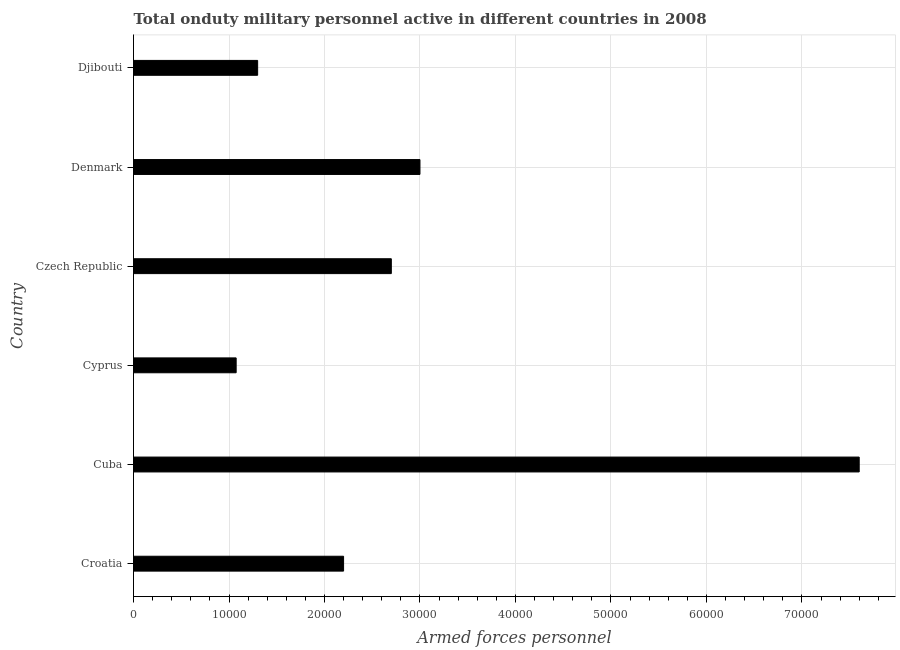Does the graph contain any zero values?
Give a very brief answer. No. Does the graph contain grids?
Your response must be concise. Yes. What is the title of the graph?
Offer a terse response. Total onduty military personnel active in different countries in 2008. What is the label or title of the X-axis?
Your response must be concise. Armed forces personnel. What is the number of armed forces personnel in Cuba?
Offer a very short reply. 7.60e+04. Across all countries, what is the maximum number of armed forces personnel?
Your answer should be compact. 7.60e+04. Across all countries, what is the minimum number of armed forces personnel?
Provide a succinct answer. 1.08e+04. In which country was the number of armed forces personnel maximum?
Your answer should be compact. Cuba. In which country was the number of armed forces personnel minimum?
Your answer should be very brief. Cyprus. What is the sum of the number of armed forces personnel?
Ensure brevity in your answer.  1.79e+05. What is the difference between the number of armed forces personnel in Cuba and Denmark?
Offer a terse response. 4.60e+04. What is the average number of armed forces personnel per country?
Give a very brief answer. 2.98e+04. What is the median number of armed forces personnel?
Offer a terse response. 2.45e+04. In how many countries, is the number of armed forces personnel greater than 70000 ?
Your response must be concise. 1. What is the ratio of the number of armed forces personnel in Denmark to that in Djibouti?
Offer a terse response. 2.31. Is the number of armed forces personnel in Czech Republic less than that in Djibouti?
Ensure brevity in your answer.  No. Is the difference between the number of armed forces personnel in Cuba and Denmark greater than the difference between any two countries?
Your answer should be very brief. No. What is the difference between the highest and the second highest number of armed forces personnel?
Offer a very short reply. 4.60e+04. Is the sum of the number of armed forces personnel in Cuba and Cyprus greater than the maximum number of armed forces personnel across all countries?
Provide a succinct answer. Yes. What is the difference between the highest and the lowest number of armed forces personnel?
Ensure brevity in your answer.  6.52e+04. What is the difference between two consecutive major ticks on the X-axis?
Make the answer very short. 10000. Are the values on the major ticks of X-axis written in scientific E-notation?
Provide a succinct answer. No. What is the Armed forces personnel of Croatia?
Give a very brief answer. 2.20e+04. What is the Armed forces personnel of Cuba?
Your answer should be very brief. 7.60e+04. What is the Armed forces personnel of Cyprus?
Your answer should be very brief. 1.08e+04. What is the Armed forces personnel of Czech Republic?
Keep it short and to the point. 2.70e+04. What is the Armed forces personnel of Djibouti?
Your answer should be very brief. 1.30e+04. What is the difference between the Armed forces personnel in Croatia and Cuba?
Keep it short and to the point. -5.40e+04. What is the difference between the Armed forces personnel in Croatia and Cyprus?
Make the answer very short. 1.12e+04. What is the difference between the Armed forces personnel in Croatia and Czech Republic?
Your answer should be compact. -5000. What is the difference between the Armed forces personnel in Croatia and Denmark?
Ensure brevity in your answer.  -8000. What is the difference between the Armed forces personnel in Croatia and Djibouti?
Your answer should be compact. 9000. What is the difference between the Armed forces personnel in Cuba and Cyprus?
Your answer should be compact. 6.52e+04. What is the difference between the Armed forces personnel in Cuba and Czech Republic?
Offer a terse response. 4.90e+04. What is the difference between the Armed forces personnel in Cuba and Denmark?
Offer a terse response. 4.60e+04. What is the difference between the Armed forces personnel in Cuba and Djibouti?
Your answer should be compact. 6.30e+04. What is the difference between the Armed forces personnel in Cyprus and Czech Republic?
Make the answer very short. -1.62e+04. What is the difference between the Armed forces personnel in Cyprus and Denmark?
Provide a short and direct response. -1.92e+04. What is the difference between the Armed forces personnel in Cyprus and Djibouti?
Your answer should be very brief. -2250. What is the difference between the Armed forces personnel in Czech Republic and Denmark?
Keep it short and to the point. -3000. What is the difference between the Armed forces personnel in Czech Republic and Djibouti?
Your answer should be compact. 1.40e+04. What is the difference between the Armed forces personnel in Denmark and Djibouti?
Provide a succinct answer. 1.70e+04. What is the ratio of the Armed forces personnel in Croatia to that in Cuba?
Your answer should be very brief. 0.29. What is the ratio of the Armed forces personnel in Croatia to that in Cyprus?
Provide a short and direct response. 2.05. What is the ratio of the Armed forces personnel in Croatia to that in Czech Republic?
Your answer should be very brief. 0.81. What is the ratio of the Armed forces personnel in Croatia to that in Denmark?
Your answer should be very brief. 0.73. What is the ratio of the Armed forces personnel in Croatia to that in Djibouti?
Offer a very short reply. 1.69. What is the ratio of the Armed forces personnel in Cuba to that in Cyprus?
Provide a short and direct response. 7.07. What is the ratio of the Armed forces personnel in Cuba to that in Czech Republic?
Keep it short and to the point. 2.81. What is the ratio of the Armed forces personnel in Cuba to that in Denmark?
Keep it short and to the point. 2.53. What is the ratio of the Armed forces personnel in Cuba to that in Djibouti?
Provide a succinct answer. 5.85. What is the ratio of the Armed forces personnel in Cyprus to that in Czech Republic?
Make the answer very short. 0.4. What is the ratio of the Armed forces personnel in Cyprus to that in Denmark?
Provide a short and direct response. 0.36. What is the ratio of the Armed forces personnel in Cyprus to that in Djibouti?
Your answer should be very brief. 0.83. What is the ratio of the Armed forces personnel in Czech Republic to that in Denmark?
Give a very brief answer. 0.9. What is the ratio of the Armed forces personnel in Czech Republic to that in Djibouti?
Your answer should be very brief. 2.08. What is the ratio of the Armed forces personnel in Denmark to that in Djibouti?
Provide a short and direct response. 2.31. 